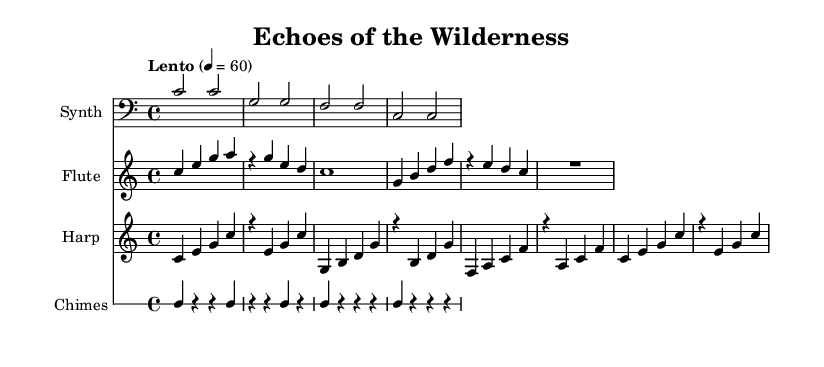What is the key signature of this music? The key signature indicated in the sheet music is C major, which has no sharps or flats.
Answer: C major What is the time signature of this music? The time signature is shown at the beginning of the score as 4/4, meaning there are four beats in each measure.
Answer: 4/4 What is the tempo marking for this piece? The tempo marking is written as "Lento" with a quarter note equals sixty beats per minute, indicating a slow pace.
Answer: Lento How many measures are in the synthesizer part? By counting the measures in the synthesizer part, there are four measures displayed in total.
Answer: Four Which instrument plays a sustained note at the end of the flute part? The flute part finishes with a whole note (R1), indicating a rest or silence for the duration of the measure, which can also be interpreted as a sustained note.
Answer: Flute What characterizes the ambient nature of this composition? The use of soft dynamics, sustained notes, and non-repetitive harmonic structures across the different instruments contributes to its ambient soundscape quality, evoking a sense of open-world exploration.
Answer: Ambient soundscape 